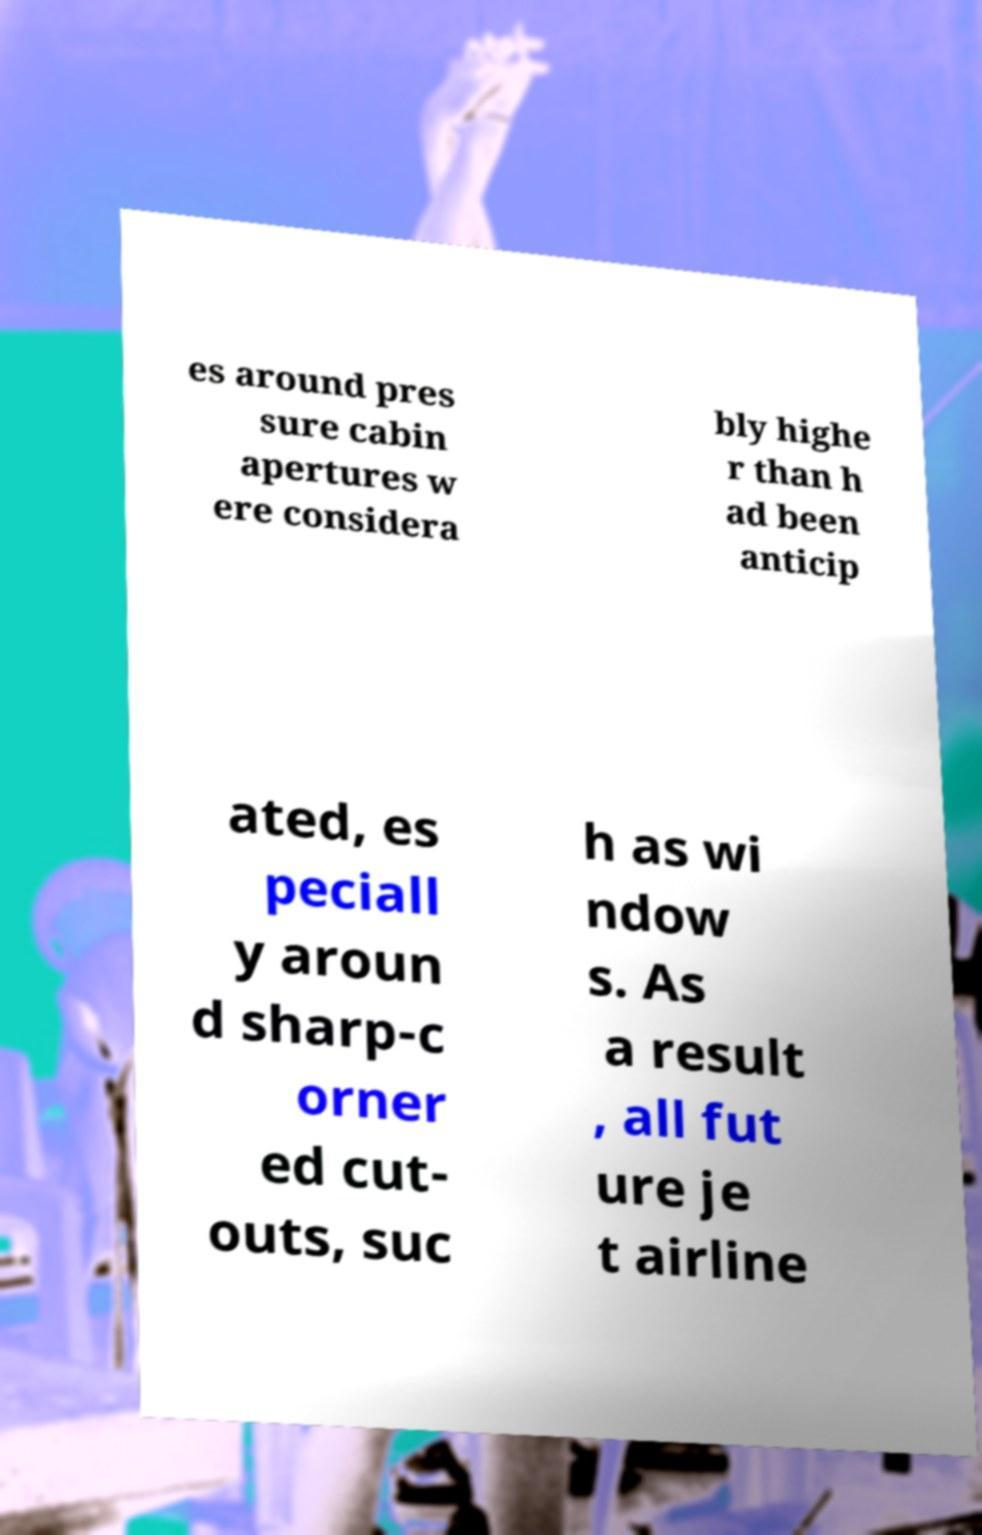There's text embedded in this image that I need extracted. Can you transcribe it verbatim? es around pres sure cabin apertures w ere considera bly highe r than h ad been anticip ated, es peciall y aroun d sharp-c orner ed cut- outs, suc h as wi ndow s. As a result , all fut ure je t airline 